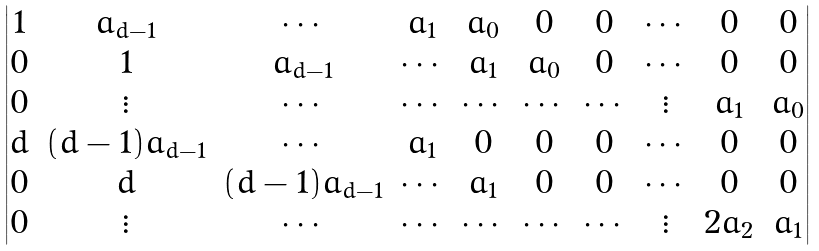Convert formula to latex. <formula><loc_0><loc_0><loc_500><loc_500>\begin{vmatrix} 1 & a _ { d - 1 } & \cdots & a _ { 1 } & a _ { 0 } & 0 & 0 & \cdots & 0 & 0 \\ 0 & 1 & a _ { d - 1 } & \cdots & a _ { 1 } & a _ { 0 } & 0 & \cdots & 0 & 0 \\ 0 & \vdots & \cdots & \cdots & \cdots & \cdots & \cdots & \vdots & a _ { 1 } & a _ { 0 } \\ d & ( d - 1 ) a _ { d - 1 } & \cdots & a _ { 1 } & 0 & 0 & 0 & \cdots & 0 & 0 \\ 0 & d & ( d - 1 ) a _ { d - 1 } & \cdots & a _ { 1 } & 0 & 0 & \cdots & 0 & 0 \\ 0 & \vdots & \cdots & \cdots & \cdots & \cdots & \cdots & \vdots & 2 a _ { 2 } & a _ { 1 } \\ \end{vmatrix}</formula> 